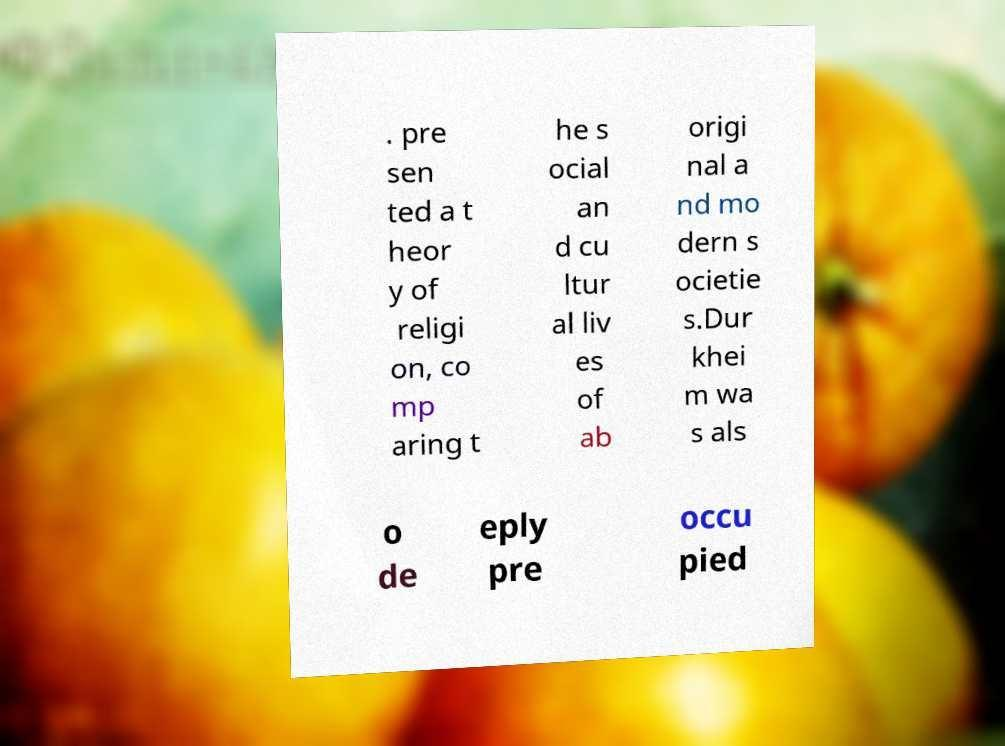There's text embedded in this image that I need extracted. Can you transcribe it verbatim? . pre sen ted a t heor y of religi on, co mp aring t he s ocial an d cu ltur al liv es of ab origi nal a nd mo dern s ocietie s.Dur khei m wa s als o de eply pre occu pied 